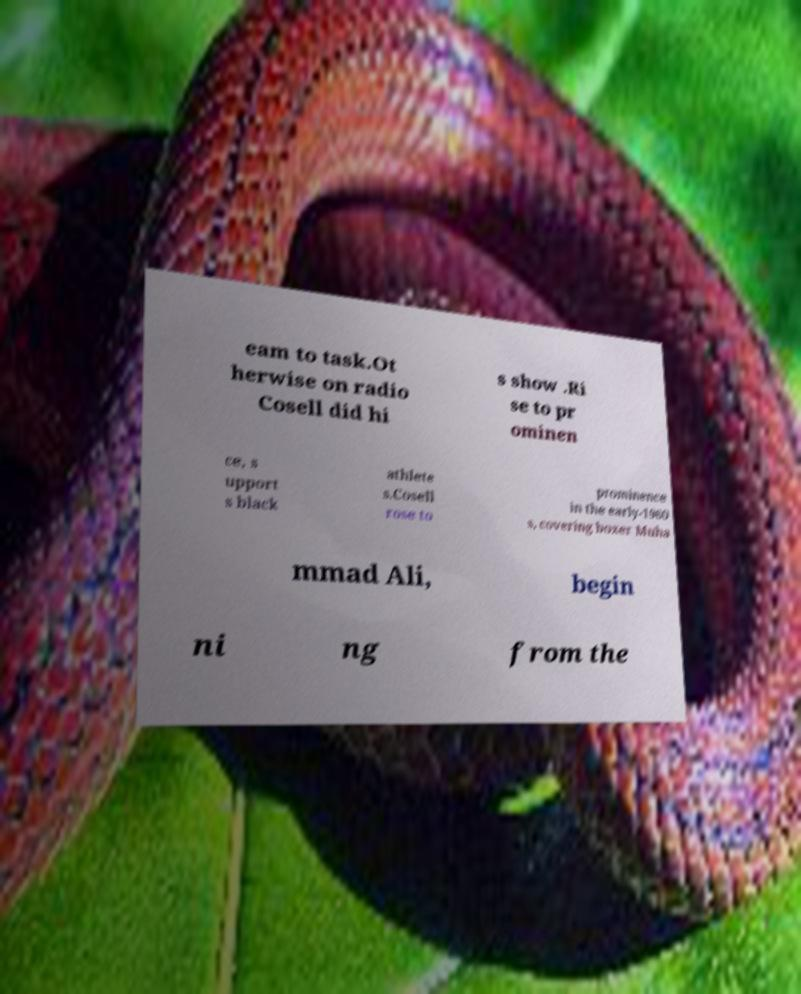There's text embedded in this image that I need extracted. Can you transcribe it verbatim? eam to task.Ot herwise on radio Cosell did hi s show .Ri se to pr ominen ce, s upport s black athlete s.Cosell rose to prominence in the early-1960 s, covering boxer Muha mmad Ali, begin ni ng from the 